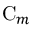Convert formula to latex. <formula><loc_0><loc_0><loc_500><loc_500>C _ { m }</formula> 